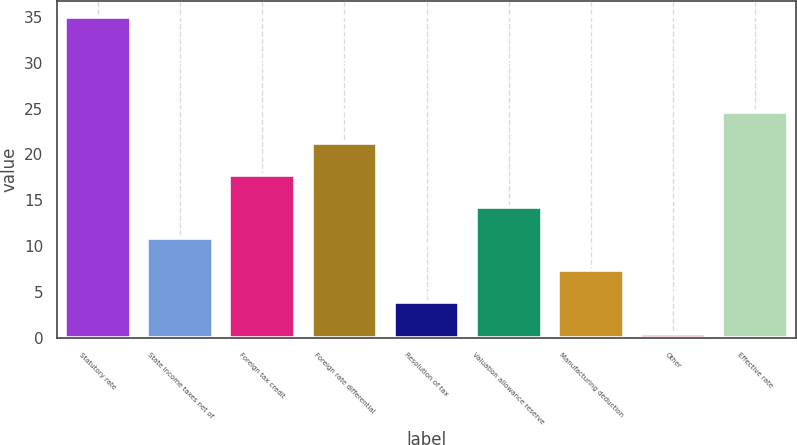Convert chart. <chart><loc_0><loc_0><loc_500><loc_500><bar_chart><fcel>Statutory rate<fcel>State income taxes net of<fcel>Foreign tax credit<fcel>Foreign rate differential<fcel>Resolution of tax<fcel>Valuation allowance reserve<fcel>Manufacturing deduction<fcel>Other<fcel>Effective rate<nl><fcel>35<fcel>10.85<fcel>17.75<fcel>21.2<fcel>3.95<fcel>14.3<fcel>7.4<fcel>0.5<fcel>24.65<nl></chart> 